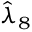<formula> <loc_0><loc_0><loc_500><loc_500>\hat { \lambda } _ { 8 }</formula> 